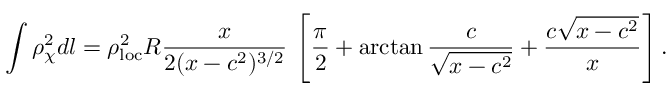<formula> <loc_0><loc_0><loc_500><loc_500>\int \rho _ { \chi } ^ { 2 } d l = \rho _ { l o c } ^ { 2 } R \frac { x } { 2 ( x - c ^ { 2 } ) ^ { 3 / 2 } } \, \left [ \frac { \pi } { 2 } + \arctan \frac { c } { \sqrt { x - c ^ { 2 } } } + \frac { c \sqrt { x - c ^ { 2 } } } { x } \right ] .</formula> 